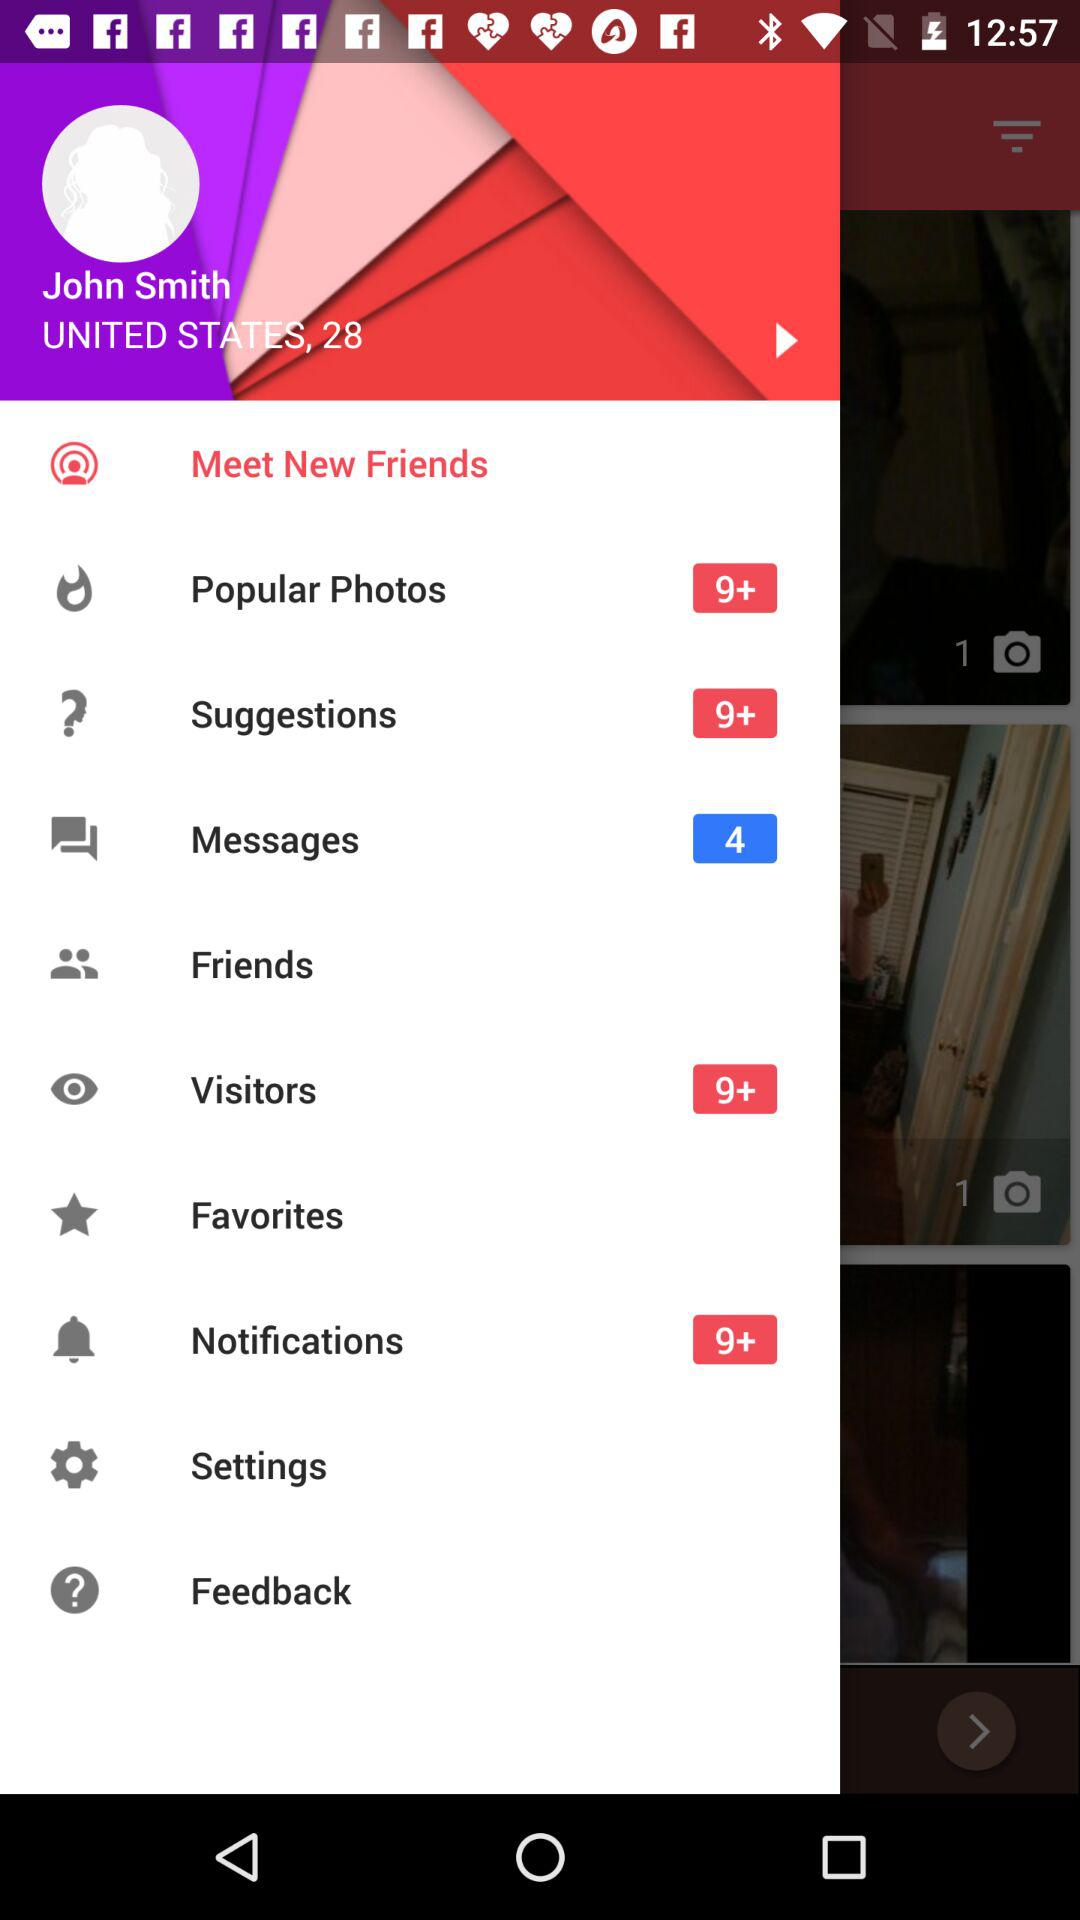How many messages are there? There are 4 messages. 